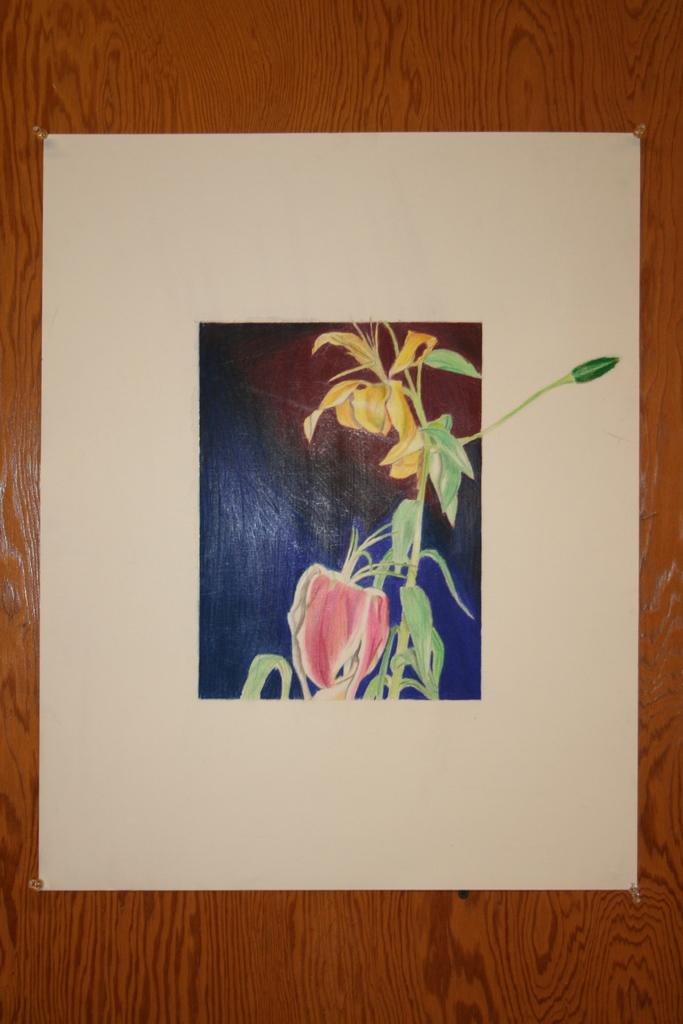What is depicted on the paper in the image? There is a picture on a paper in the image. Where is the paper with the picture located? The paper with the picture is pasted on a wall. Can you see any caves in the image? There are no caves visible in the image; it features a paper with a picture on it that is pasted on a wall. Are there any people running in the image? There are no people or running depicted in the image. 